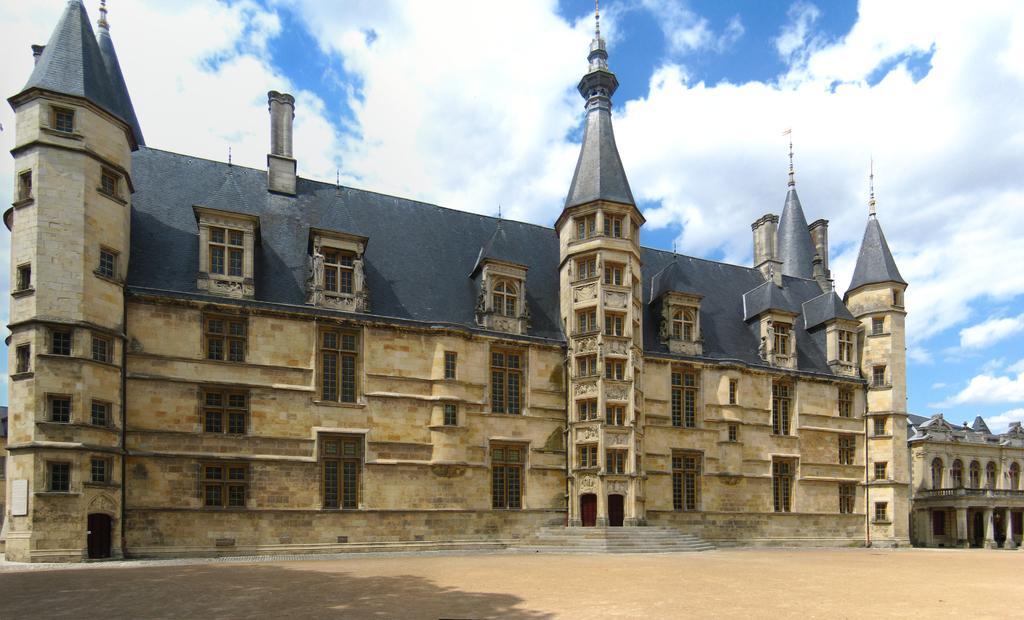In one or two sentences, can you explain what this image depicts? In this image, we can see buildings. There are clouds in the sky. 